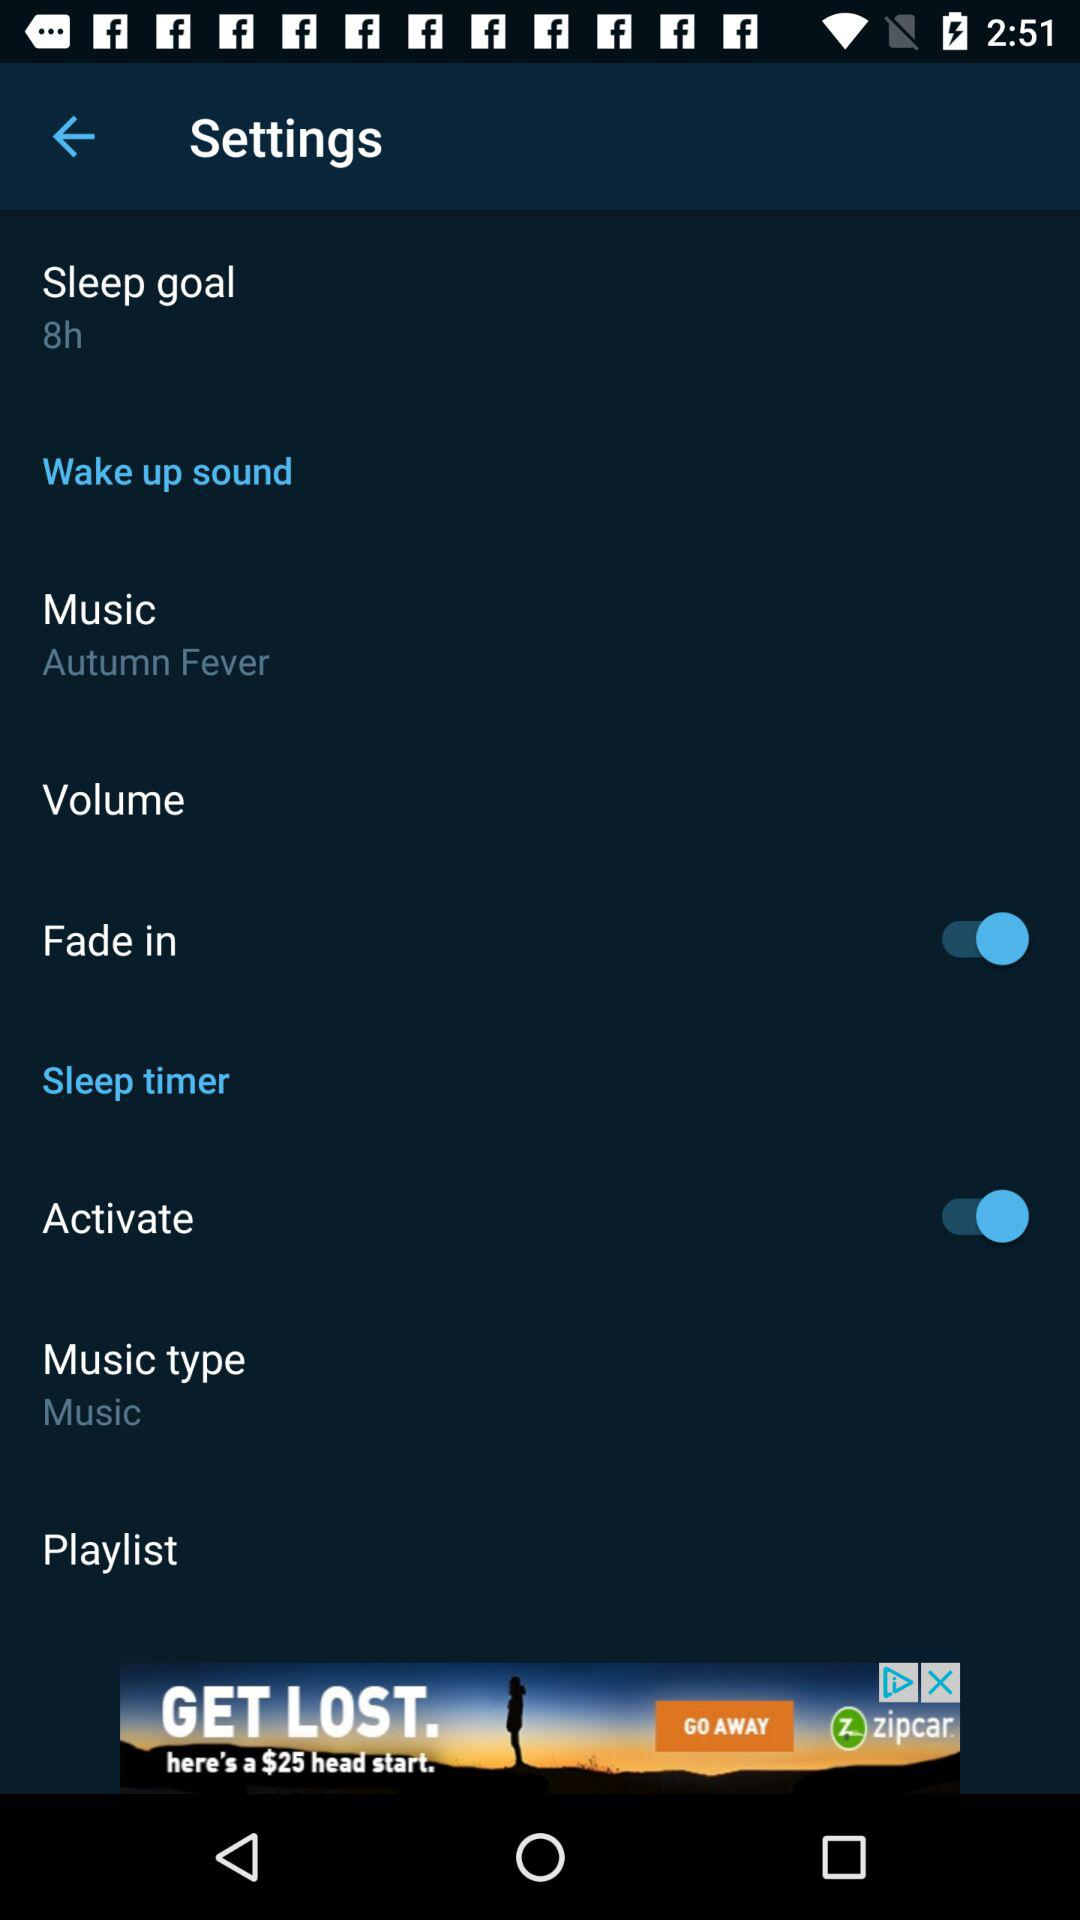What is the setting for the sleep goal? The setting is "8h". 